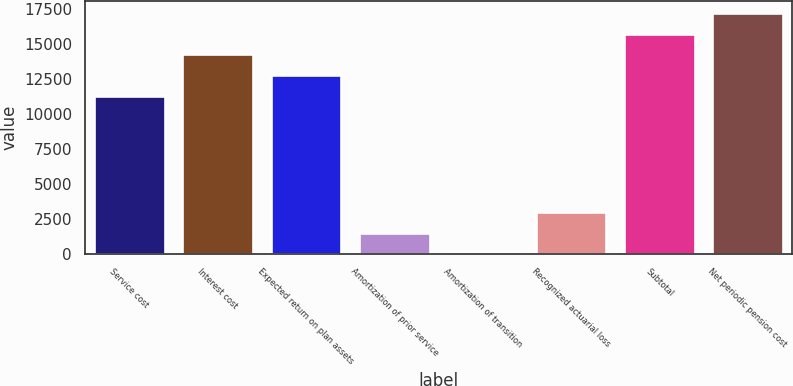Convert chart to OTSL. <chart><loc_0><loc_0><loc_500><loc_500><bar_chart><fcel>Service cost<fcel>Interest cost<fcel>Expected return on plan assets<fcel>Amortization of prior service<fcel>Amortization of transition<fcel>Recognized actuarial loss<fcel>Subtotal<fcel>Net periodic pension cost<nl><fcel>11323<fcel>14291.8<fcel>12807.4<fcel>1504.4<fcel>20<fcel>2999<fcel>15776.2<fcel>17260.6<nl></chart> 